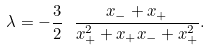<formula> <loc_0><loc_0><loc_500><loc_500>\lambda = - \frac { 3 } { 2 } \ \frac { x _ { - } + x _ { + } } { x _ { + } ^ { 2 } + x _ { + } x _ { - } + x _ { + } ^ { 2 } } .</formula> 